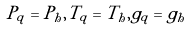Convert formula to latex. <formula><loc_0><loc_0><loc_500><loc_500>P _ { q } = P _ { h } , T _ { q } = T _ { h } , g _ { q } = g _ { h }</formula> 